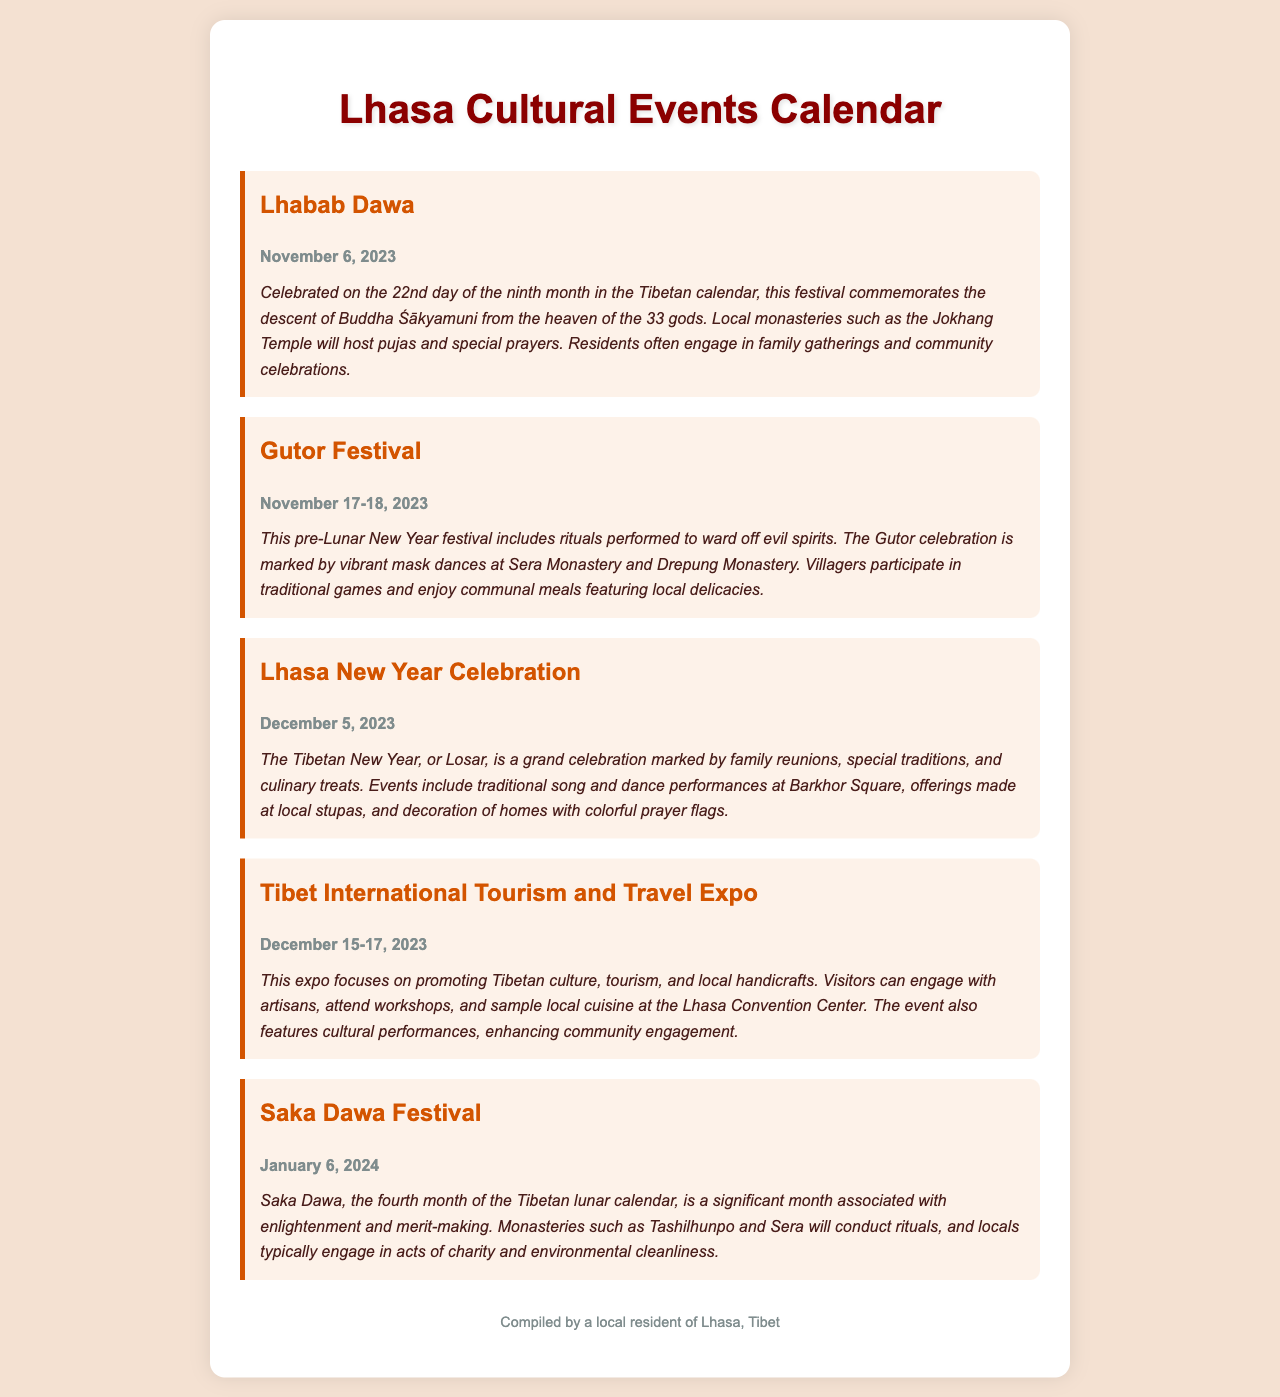What is the date of Lhabab Dawa? The document specifies that Lhabab Dawa is celebrated on November 6, 2023.
Answer: November 6, 2023 What two monasteries will host the Gutor Festival celebrations? The Gutor Festival celebrations will be held at Sera Monastery and Drepung Monastery.
Answer: Sera Monastery and Drepung Monastery What is the date range for the Tibet International Tourism and Travel Expo? The document states the expo takes place from December 15 to December 17, 2023.
Answer: December 15-17, 2023 Which festival is associated with the fourth month of the Tibetan lunar calendar? The festival that corresponds with the fourth month of the Tibetan lunar calendar is Saka Dawa.
Answer: Saka Dawa What type of activities are included in the Lhasa New Year Celebration? The Lhasa New Year Celebration includes traditional song and dance performances, offerings at local stupas, and home decorations.
Answer: Traditional song and dance performances, offerings at local stupas, and home decorations What is the primary focus of the Tibet International Tourism and Travel Expo? The primary focus of the expo is to promote Tibetan culture, tourism, and local handicrafts.
Answer: Promoting Tibetan culture, tourism, and local handicrafts How does the community typically celebrate Lhabab Dawa? The community engages in family gatherings and community celebrations during Lhabab Dawa.
Answer: Family gatherings and community celebrations What is the significance of Saka Dawa? Saka Dawa is significant for its association with enlightenment and merit-making.
Answer: Enlightenment and merit-making 